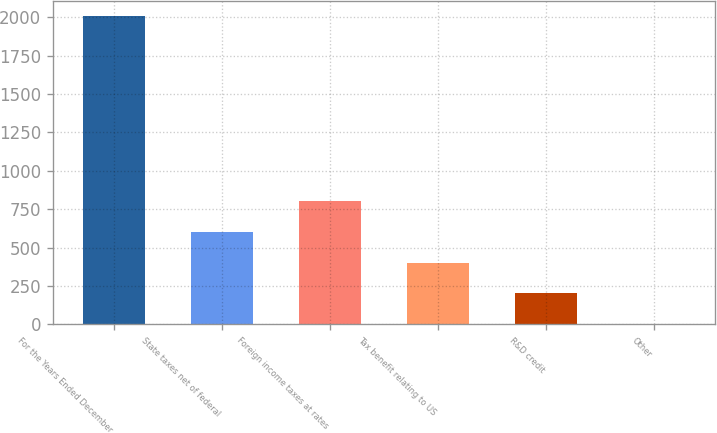<chart> <loc_0><loc_0><loc_500><loc_500><bar_chart><fcel>For the Years Ended December<fcel>State taxes net of federal<fcel>Foreign income taxes at rates<fcel>Tax benefit relating to US<fcel>R&D credit<fcel>Other<nl><fcel>2007<fcel>602.24<fcel>802.92<fcel>401.56<fcel>200.88<fcel>0.2<nl></chart> 